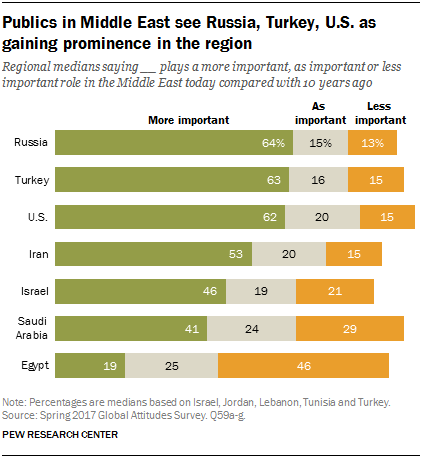Draw attention to some important aspects in this diagram. The value of "0.62" is considered more important for the United States. The values for "More important" and "Less important" are the highest for Russia, and the highest for Egypt, respectively. 